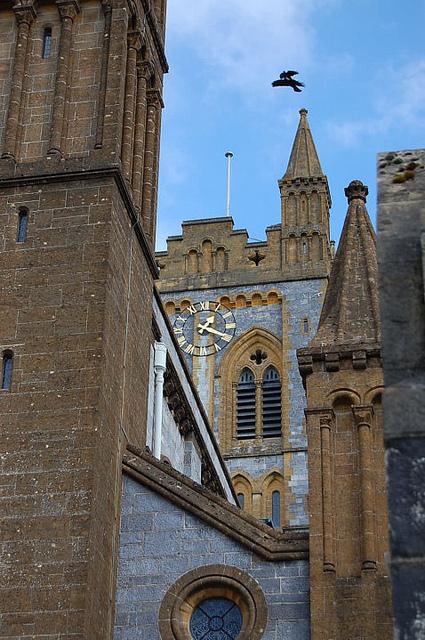How many arches are there?
Be succinct. 1. How tall are the buildings?
Short answer required. Very. What's on the building?
Write a very short answer. Clock. What point of view is this picture taken?
Give a very brief answer. Ground. What time is on the clock?
Write a very short answer. 1:20. What color is the building?
Concise answer only. Brown. Is there a clock on this building?
Keep it brief. Yes. What is the most distinctive feature on the building?
Quick response, please. Clock. Could these buildings be in Europe?
Concise answer only. Yes. 